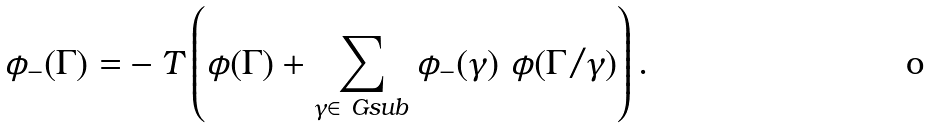Convert formula to latex. <formula><loc_0><loc_0><loc_500><loc_500>\phi _ { - } ( \Gamma ) = & - T \left ( \phi ( \Gamma ) + \sum _ { \gamma \in \ G s u b } \phi _ { - } ( \gamma ) \ \phi ( \Gamma / \gamma ) \right ) .</formula> 